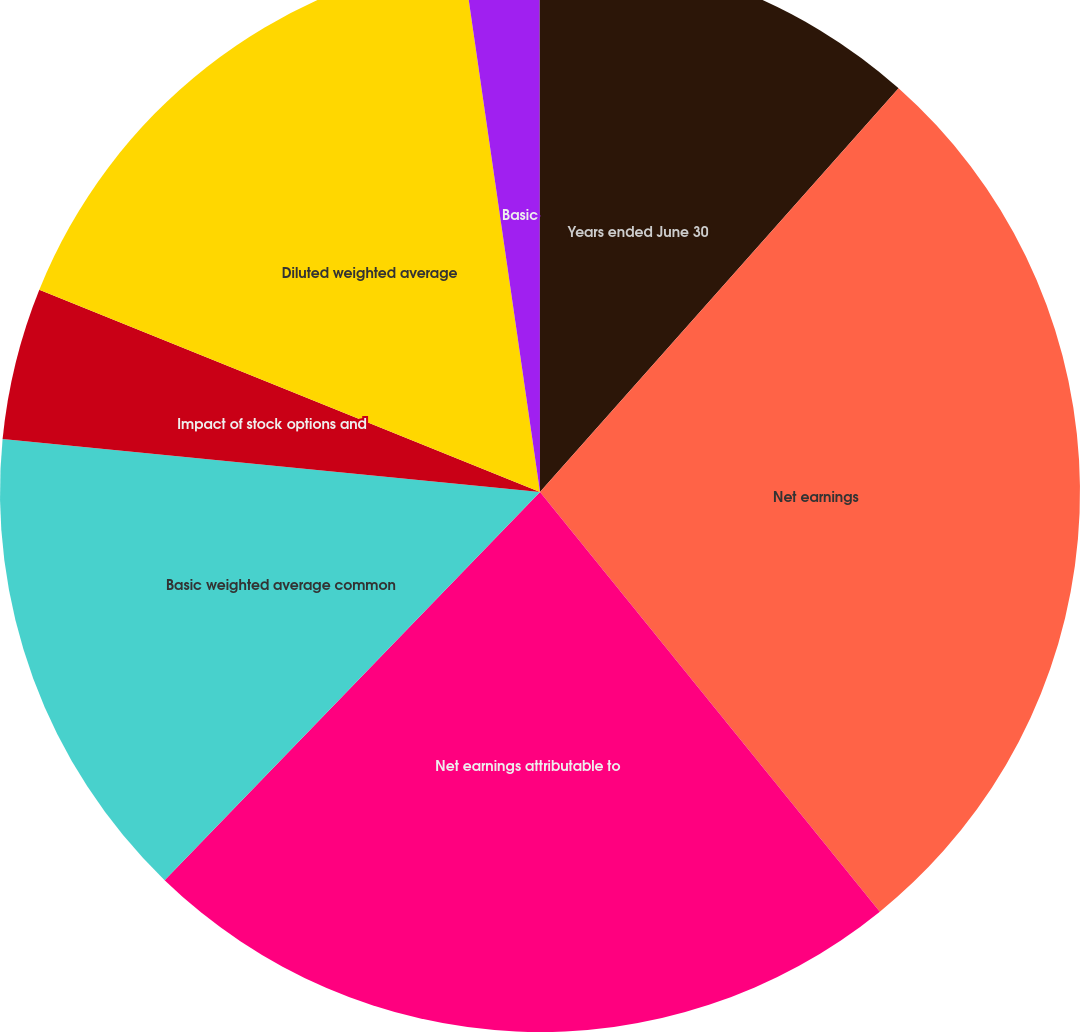<chart> <loc_0><loc_0><loc_500><loc_500><pie_chart><fcel>Years ended June 30<fcel>Net earnings<fcel>Net earnings attributable to<fcel>Basic weighted average common<fcel>Impact of stock options and<fcel>Diluted weighted average<fcel>Basic<fcel>Diluted<nl><fcel>11.56%<fcel>27.61%<fcel>23.07%<fcel>14.33%<fcel>4.55%<fcel>16.6%<fcel>2.28%<fcel>0.01%<nl></chart> 